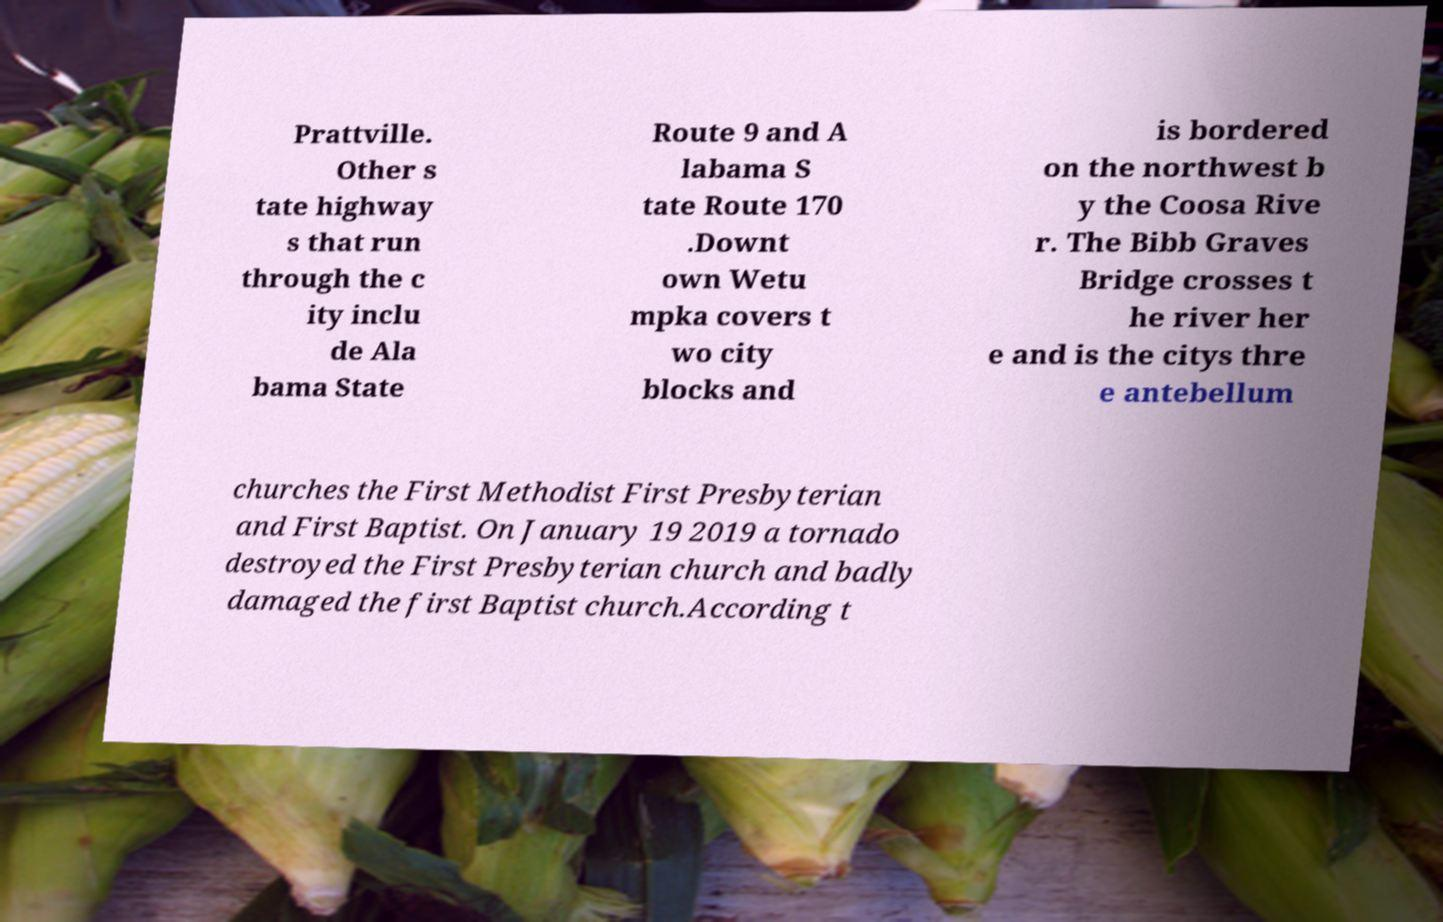Can you accurately transcribe the text from the provided image for me? Prattville. Other s tate highway s that run through the c ity inclu de Ala bama State Route 9 and A labama S tate Route 170 .Downt own Wetu mpka covers t wo city blocks and is bordered on the northwest b y the Coosa Rive r. The Bibb Graves Bridge crosses t he river her e and is the citys thre e antebellum churches the First Methodist First Presbyterian and First Baptist. On January 19 2019 a tornado destroyed the First Presbyterian church and badly damaged the first Baptist church.According t 